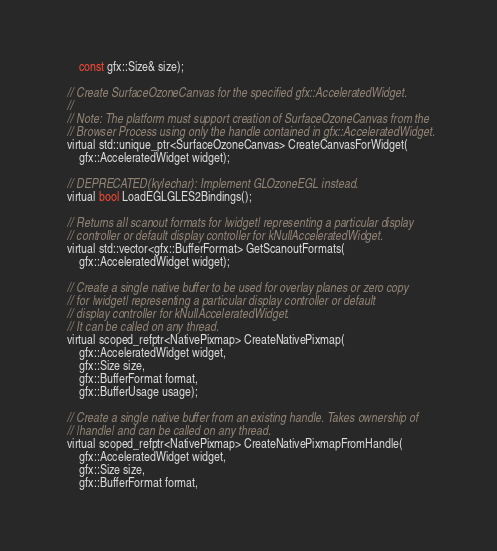Convert code to text. <code><loc_0><loc_0><loc_500><loc_500><_C_>      const gfx::Size& size);

  // Create SurfaceOzoneCanvas for the specified gfx::AcceleratedWidget.
  //
  // Note: The platform must support creation of SurfaceOzoneCanvas from the
  // Browser Process using only the handle contained in gfx::AcceleratedWidget.
  virtual std::unique_ptr<SurfaceOzoneCanvas> CreateCanvasForWidget(
      gfx::AcceleratedWidget widget);

  // DEPRECATED(kylechar): Implement GLOzoneEGL instead.
  virtual bool LoadEGLGLES2Bindings();

  // Returns all scanout formats for |widget| representing a particular display
  // controller or default display controller for kNullAcceleratedWidget.
  virtual std::vector<gfx::BufferFormat> GetScanoutFormats(
      gfx::AcceleratedWidget widget);

  // Create a single native buffer to be used for overlay planes or zero copy
  // for |widget| representing a particular display controller or default
  // display controller for kNullAcceleratedWidget.
  // It can be called on any thread.
  virtual scoped_refptr<NativePixmap> CreateNativePixmap(
      gfx::AcceleratedWidget widget,
      gfx::Size size,
      gfx::BufferFormat format,
      gfx::BufferUsage usage);

  // Create a single native buffer from an existing handle. Takes ownership of
  // |handle| and can be called on any thread.
  virtual scoped_refptr<NativePixmap> CreateNativePixmapFromHandle(
      gfx::AcceleratedWidget widget,
      gfx::Size size,
      gfx::BufferFormat format,</code> 